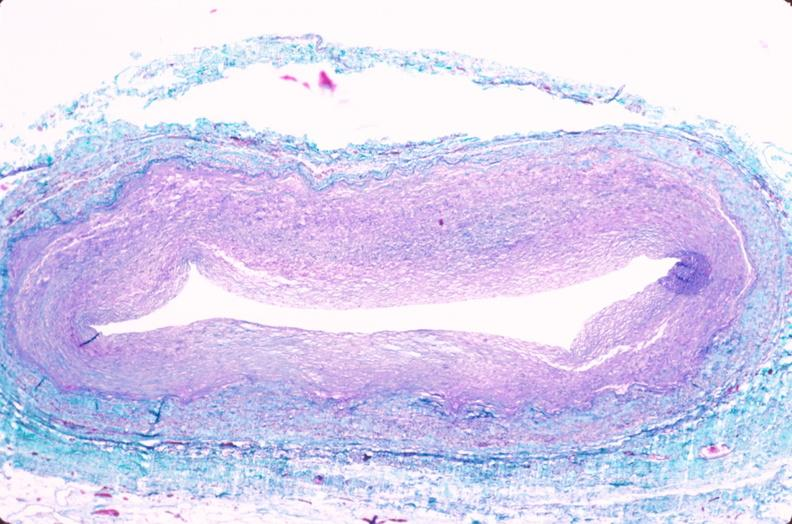does leiomyosarcoma show saphenous vein graft sclerosis?
Answer the question using a single word or phrase. No 